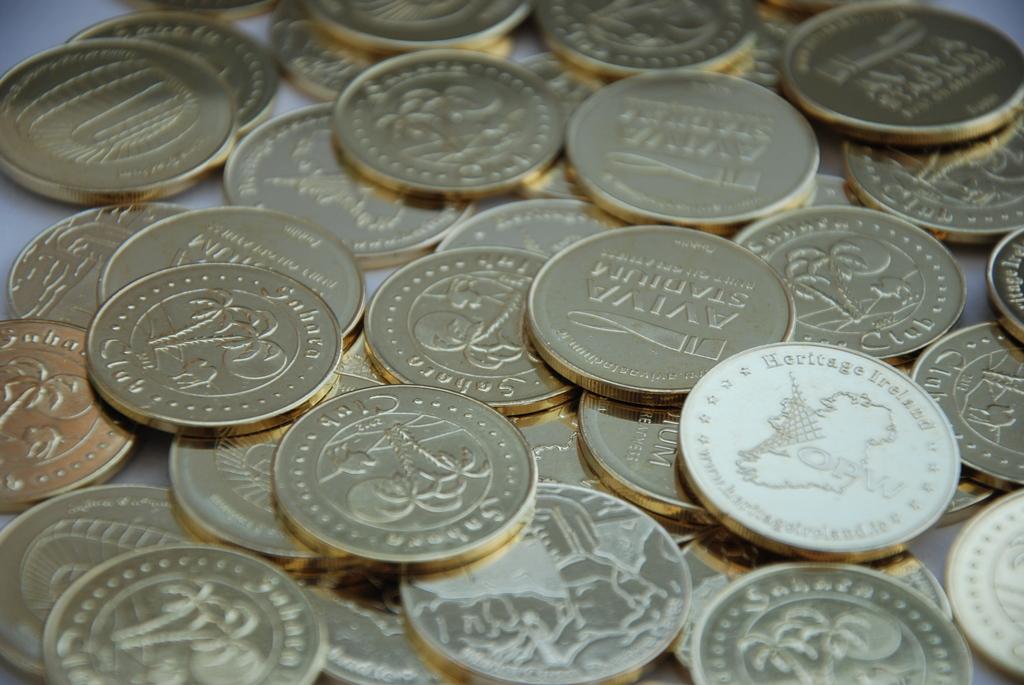What does the coin say?
Your answer should be compact. Heritage ireland. 